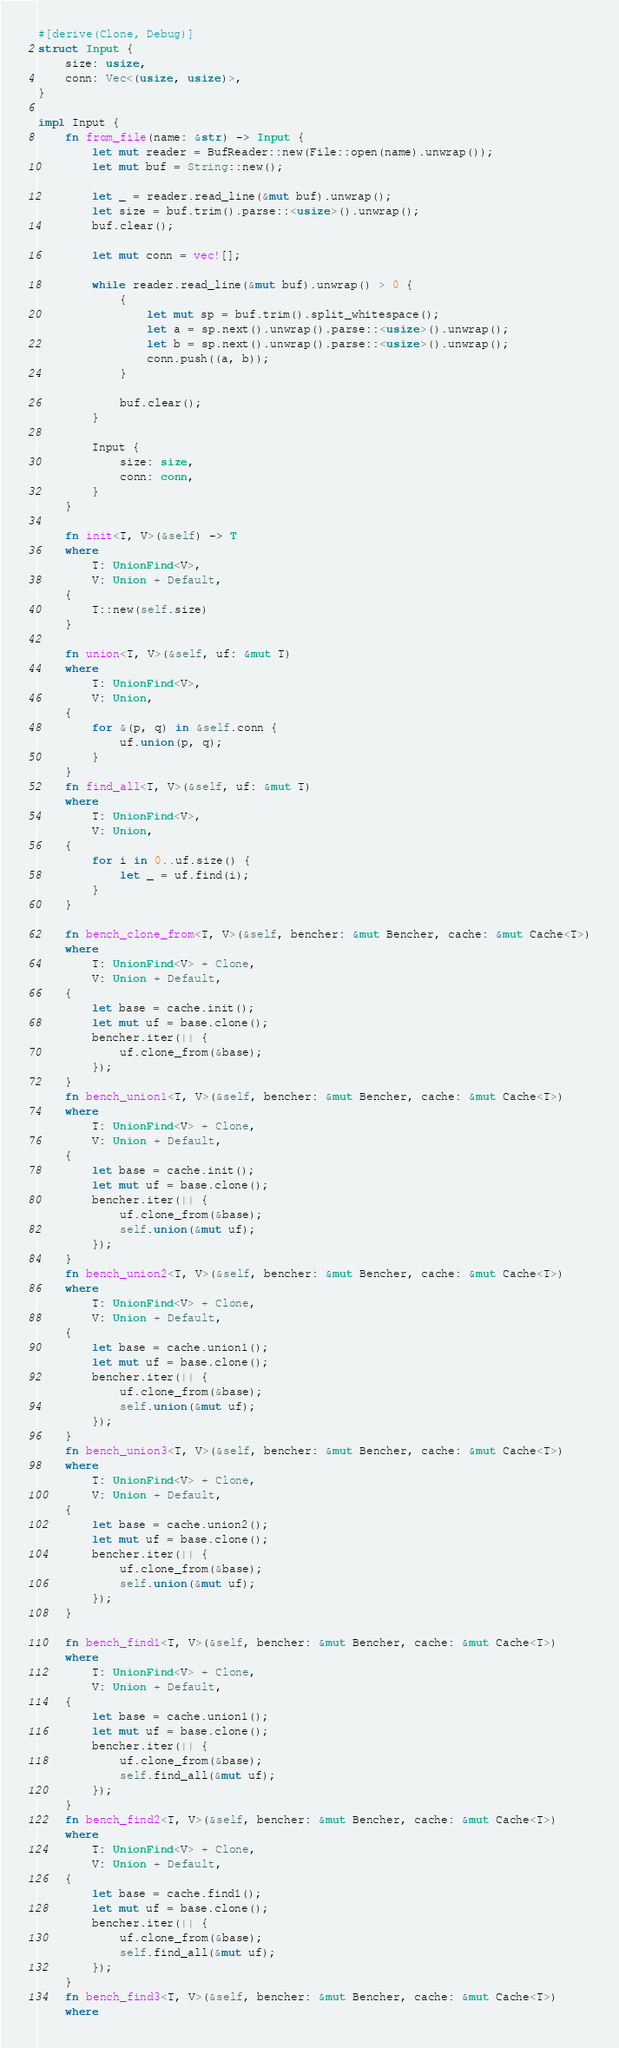<code> <loc_0><loc_0><loc_500><loc_500><_Rust_>#[derive(Clone, Debug)]
struct Input {
    size: usize,
    conn: Vec<(usize, usize)>,
}

impl Input {
    fn from_file(name: &str) -> Input {
        let mut reader = BufReader::new(File::open(name).unwrap());
        let mut buf = String::new();

        let _ = reader.read_line(&mut buf).unwrap();
        let size = buf.trim().parse::<usize>().unwrap();
        buf.clear();

        let mut conn = vec![];

        while reader.read_line(&mut buf).unwrap() > 0 {
            {
                let mut sp = buf.trim().split_whitespace();
                let a = sp.next().unwrap().parse::<usize>().unwrap();
                let b = sp.next().unwrap().parse::<usize>().unwrap();
                conn.push((a, b));
            }

            buf.clear();
        }

        Input {
            size: size,
            conn: conn,
        }
    }

    fn init<T, V>(&self) -> T
    where
        T: UnionFind<V>,
        V: Union + Default,
    {
        T::new(self.size)
    }

    fn union<T, V>(&self, uf: &mut T)
    where
        T: UnionFind<V>,
        V: Union,
    {
        for &(p, q) in &self.conn {
            uf.union(p, q);
        }
    }
    fn find_all<T, V>(&self, uf: &mut T)
    where
        T: UnionFind<V>,
        V: Union,
    {
        for i in 0..uf.size() {
            let _ = uf.find(i);
        }
    }

    fn bench_clone_from<T, V>(&self, bencher: &mut Bencher, cache: &mut Cache<T>)
    where
        T: UnionFind<V> + Clone,
        V: Union + Default,
    {
        let base = cache.init();
        let mut uf = base.clone();
        bencher.iter(|| {
            uf.clone_from(&base);
        });
    }
    fn bench_union1<T, V>(&self, bencher: &mut Bencher, cache: &mut Cache<T>)
    where
        T: UnionFind<V> + Clone,
        V: Union + Default,
    {
        let base = cache.init();
        let mut uf = base.clone();
        bencher.iter(|| {
            uf.clone_from(&base);
            self.union(&mut uf);
        });
    }
    fn bench_union2<T, V>(&self, bencher: &mut Bencher, cache: &mut Cache<T>)
    where
        T: UnionFind<V> + Clone,
        V: Union + Default,
    {
        let base = cache.union1();
        let mut uf = base.clone();
        bencher.iter(|| {
            uf.clone_from(&base);
            self.union(&mut uf);
        });
    }
    fn bench_union3<T, V>(&self, bencher: &mut Bencher, cache: &mut Cache<T>)
    where
        T: UnionFind<V> + Clone,
        V: Union + Default,
    {
        let base = cache.union2();
        let mut uf = base.clone();
        bencher.iter(|| {
            uf.clone_from(&base);
            self.union(&mut uf);
        });
    }

    fn bench_find1<T, V>(&self, bencher: &mut Bencher, cache: &mut Cache<T>)
    where
        T: UnionFind<V> + Clone,
        V: Union + Default,
    {
        let base = cache.union1();
        let mut uf = base.clone();
        bencher.iter(|| {
            uf.clone_from(&base);
            self.find_all(&mut uf);
        });
    }
    fn bench_find2<T, V>(&self, bencher: &mut Bencher, cache: &mut Cache<T>)
    where
        T: UnionFind<V> + Clone,
        V: Union + Default,
    {
        let base = cache.find1();
        let mut uf = base.clone();
        bencher.iter(|| {
            uf.clone_from(&base);
            self.find_all(&mut uf);
        });
    }
    fn bench_find3<T, V>(&self, bencher: &mut Bencher, cache: &mut Cache<T>)
    where</code> 